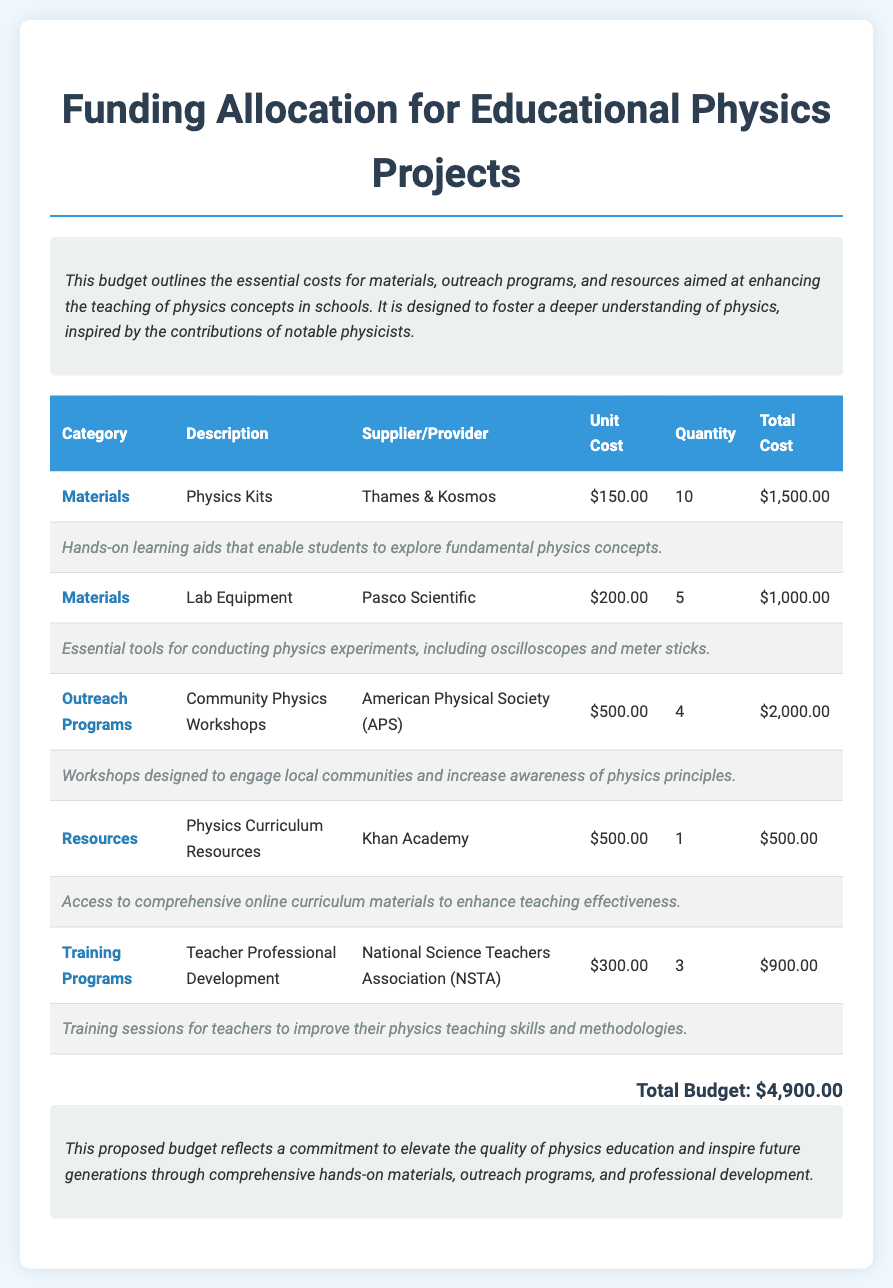what is the total budget? The total budget is stated at the end of the document as the summation of all costs listed.
Answer: $4,900.00 who provided the Physics Kits? The supplier of the Physics Kits is mentioned in the materials section of the document.
Answer: Thames & Kosmos how many community workshops are planned? The document lists the quantity of community physics workshops under the outreach programs section.
Answer: 4 what is the unit cost for teacher professional development? The unit cost for teacher professional development is specified next to the corresponding training program in the document.
Answer: $300.00 what type of resources are included in the budget? The document describes resources that aim to improve physics teaching and mentions specific types.
Answer: Physics Curriculum Resources why are hands-on learning aids important? The justification for the materials states their role in exploring fundamental physics concepts.
Answer: To enable students to explore fundamental physics concepts 